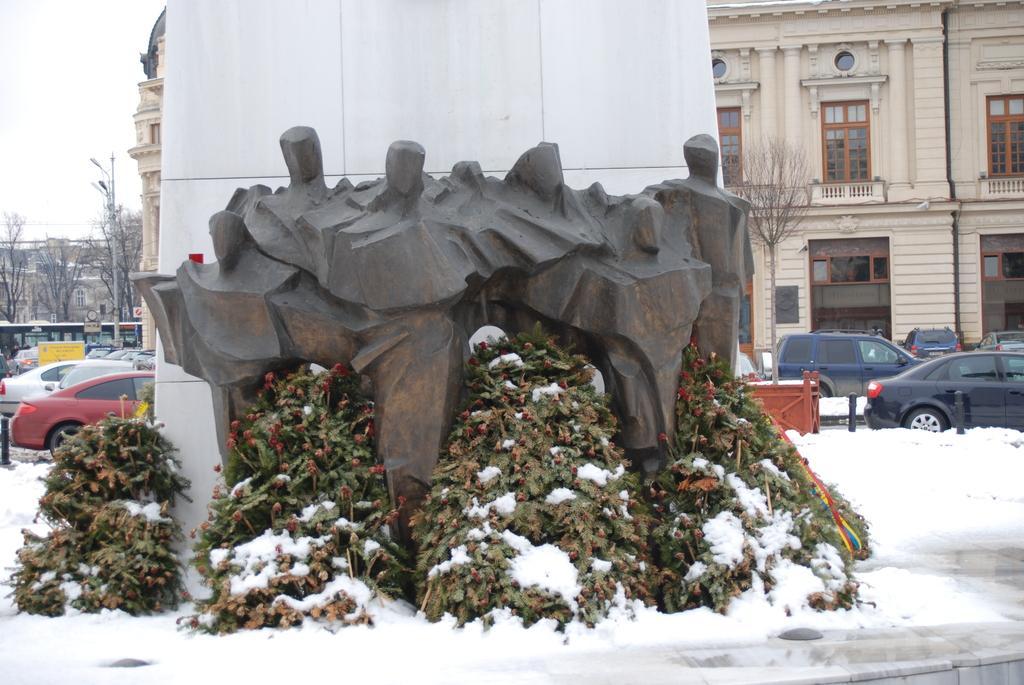Please provide a concise description of this image. In this picture we can observe a carved stone. There are some plants in front of this stone which were covered with some snow. There are some cars which were in black, red and white colors. In the background we can observe dried trees and a cream color building on the right side. We can observe a sky on the left side. 